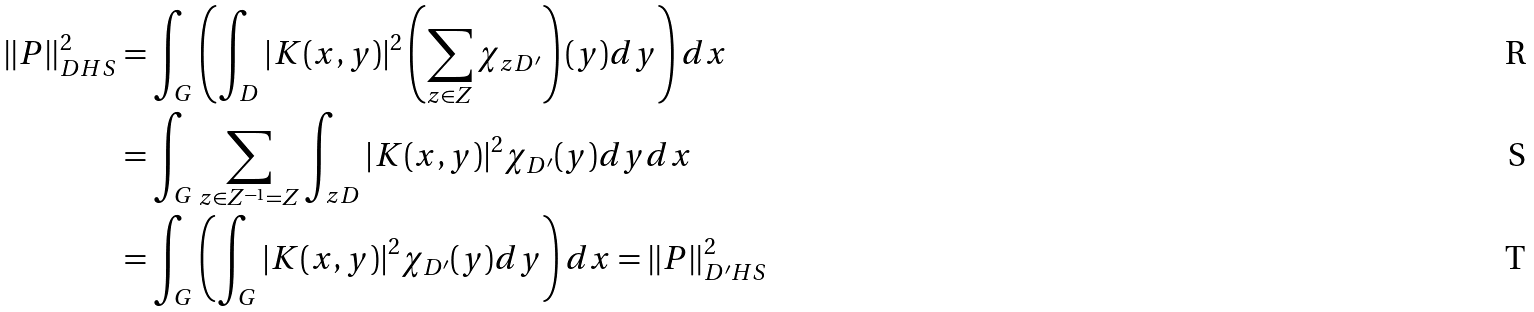Convert formula to latex. <formula><loc_0><loc_0><loc_500><loc_500>\| P \| _ { D H S } ^ { 2 } & = \int _ { G } \left ( \int _ { D } | K ( x , y ) | ^ { 2 } \left ( \sum _ { z \in Z } \chi _ { z D ^ { \prime } } \right ) ( y ) d y \right ) d x \\ & = \int _ { G } \sum _ { z \in Z ^ { - 1 } = Z } \int _ { z D } | K ( x , y ) | ^ { 2 } \chi _ { D ^ { \prime } } ( y ) d y d x \\ & = \int _ { G } \left ( \int _ { G } | K ( x , y ) | ^ { 2 } \chi _ { D ^ { \prime } } ( y ) d y \right ) d x = \| P \| _ { D ^ { \prime } H S } ^ { 2 }</formula> 